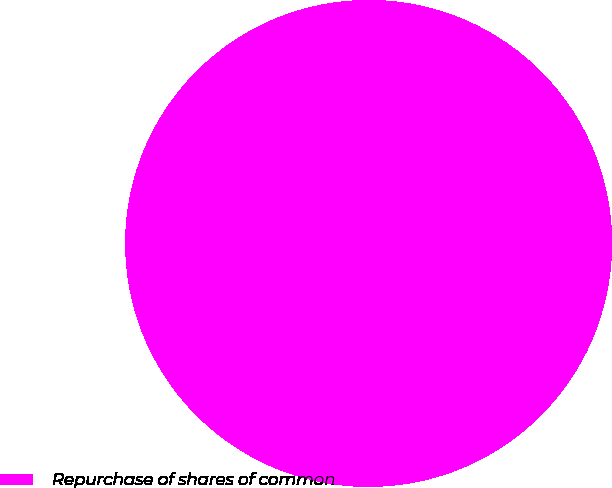Convert chart. <chart><loc_0><loc_0><loc_500><loc_500><pie_chart><fcel>Repurchase of shares of common<nl><fcel>100.0%<nl></chart> 